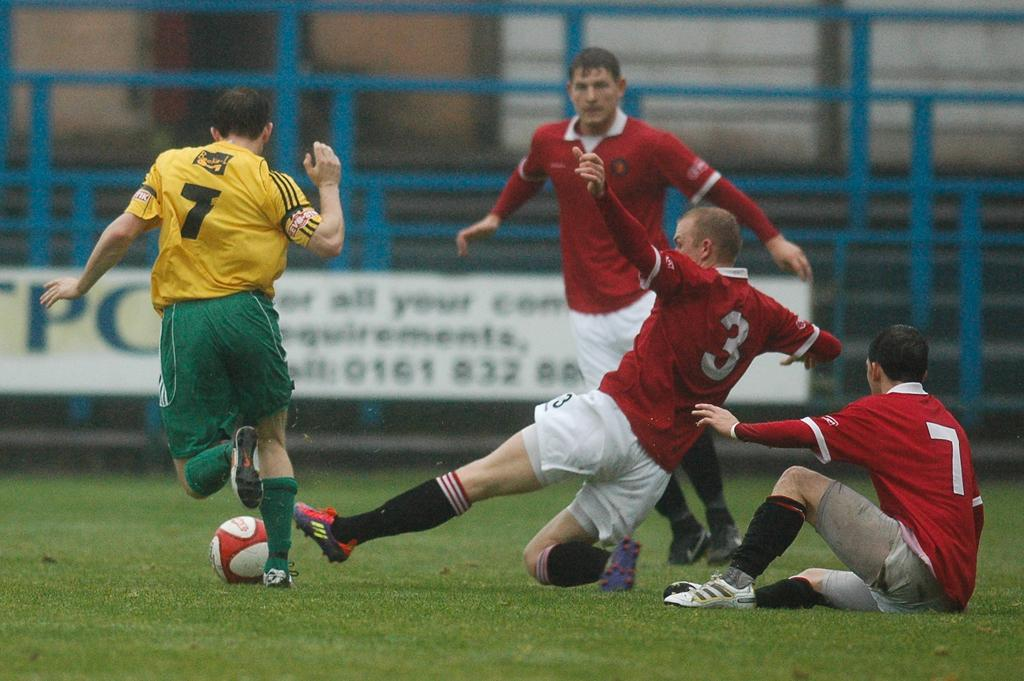<image>
Create a compact narrative representing the image presented. One man wearing a number 7 shirt is playing soccer against three men wearing red shirts, with the number 3 player attempting to intercept. 